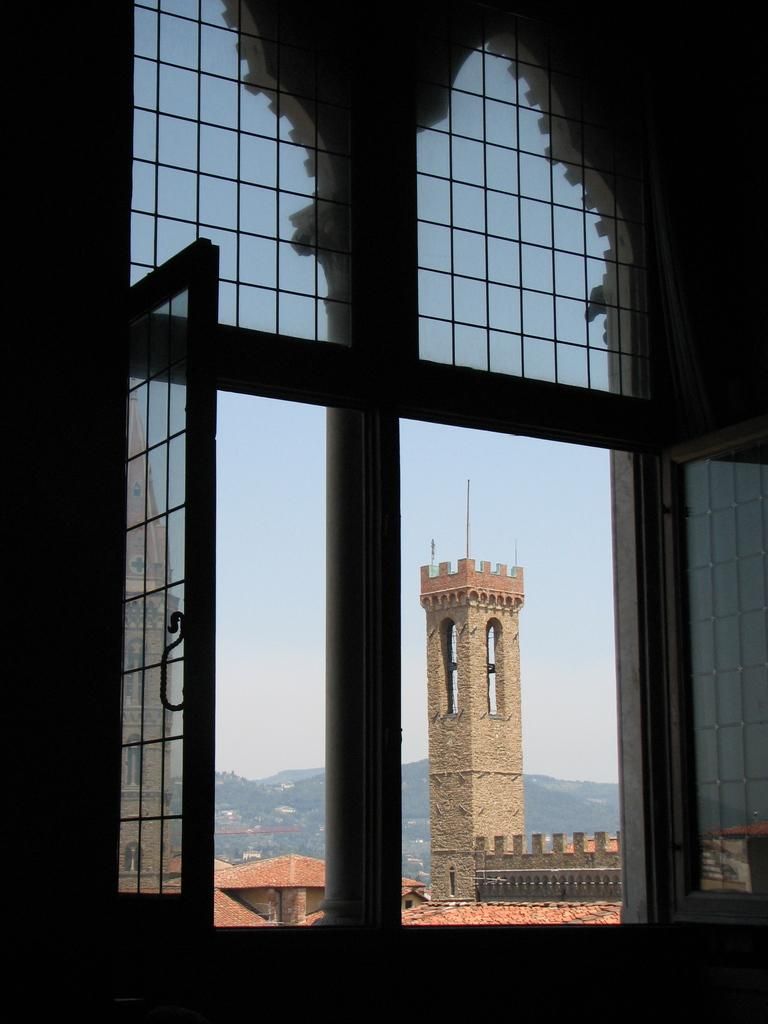What can be seen through the window in the image? There is a building and mountains visible behind the window. What else is visible through the window? The sky is visible behind the window. Can you describe the view through the window? The view through the window includes a building, mountains, and the sky. How many corks are floating in the sky during the rainstorm in the image? There is no rainstorm or corks present in the image. 